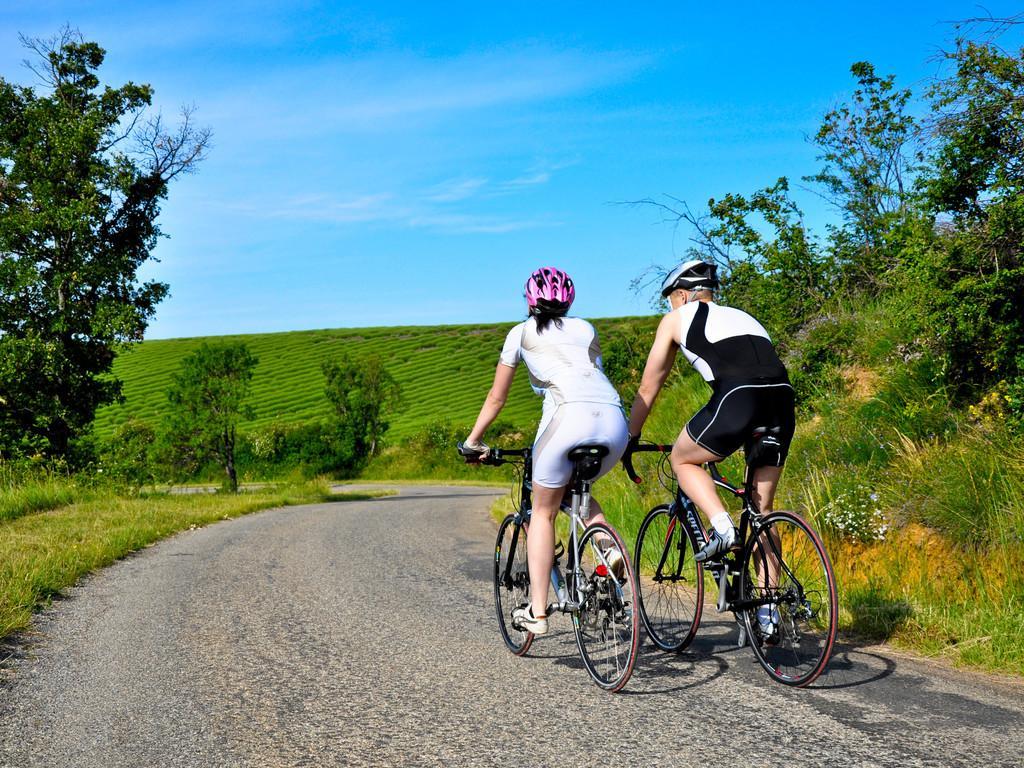Could you give a brief overview of what you see in this image? In this image I can see two people are cycling their cycles. I can also see both of them are wearing helmets. In the background I can see number of trees, grass and clear view of sky. 